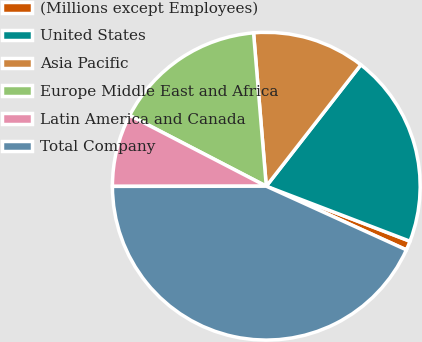<chart> <loc_0><loc_0><loc_500><loc_500><pie_chart><fcel>(Millions except Employees)<fcel>United States<fcel>Asia Pacific<fcel>Europe Middle East and Africa<fcel>Latin America and Canada<fcel>Total Company<nl><fcel>0.97%<fcel>20.29%<fcel>11.85%<fcel>16.07%<fcel>7.63%<fcel>43.19%<nl></chart> 